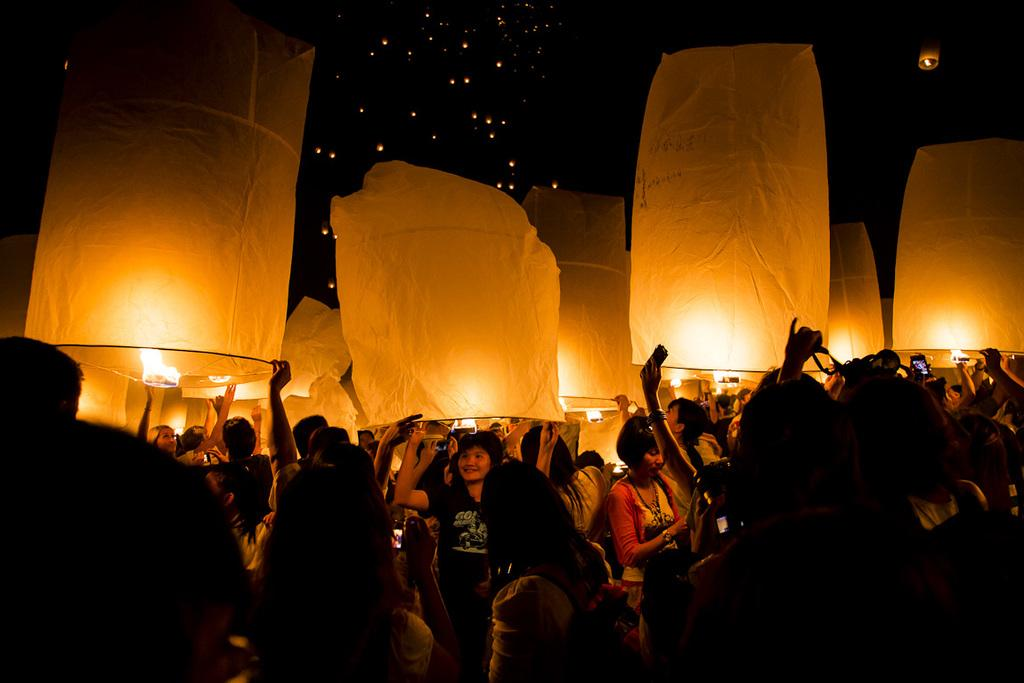How many people are in the image? There is a group of people in the image, but the exact number is not specified. What are the people doing in the image? The people are standing and holding sky lanterns. What is the color of the sky in the background? The sky in the background is black. What else can be seen in the image besides the people and sky lanterns? There are lights visible in the image. What type of account is being discussed in the image? There is no mention of an account in the image; it features a group of people holding sky lanterns with a black sky in the background and lights visible. Is there an umbrella present in the image? There is no umbrella present in the image. 